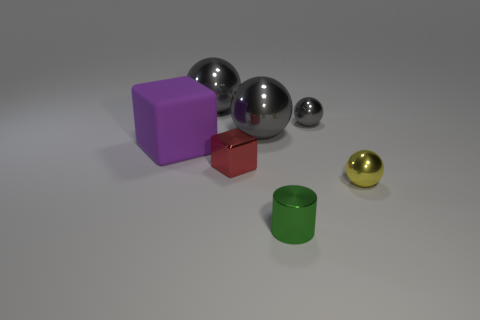How many gray balls must be subtracted to get 1 gray balls? 2 Subtract all yellow balls. How many balls are left? 3 Add 2 large purple objects. How many objects exist? 9 Subtract all red blocks. How many blocks are left? 1 Subtract all balls. How many objects are left? 3 Subtract 1 blocks. How many blocks are left? 1 Subtract all yellow balls. Subtract all gray cylinders. How many balls are left? 3 Subtract all gray cylinders. How many red blocks are left? 1 Subtract all tiny gray metal cylinders. Subtract all small green metallic things. How many objects are left? 6 Add 7 green objects. How many green objects are left? 8 